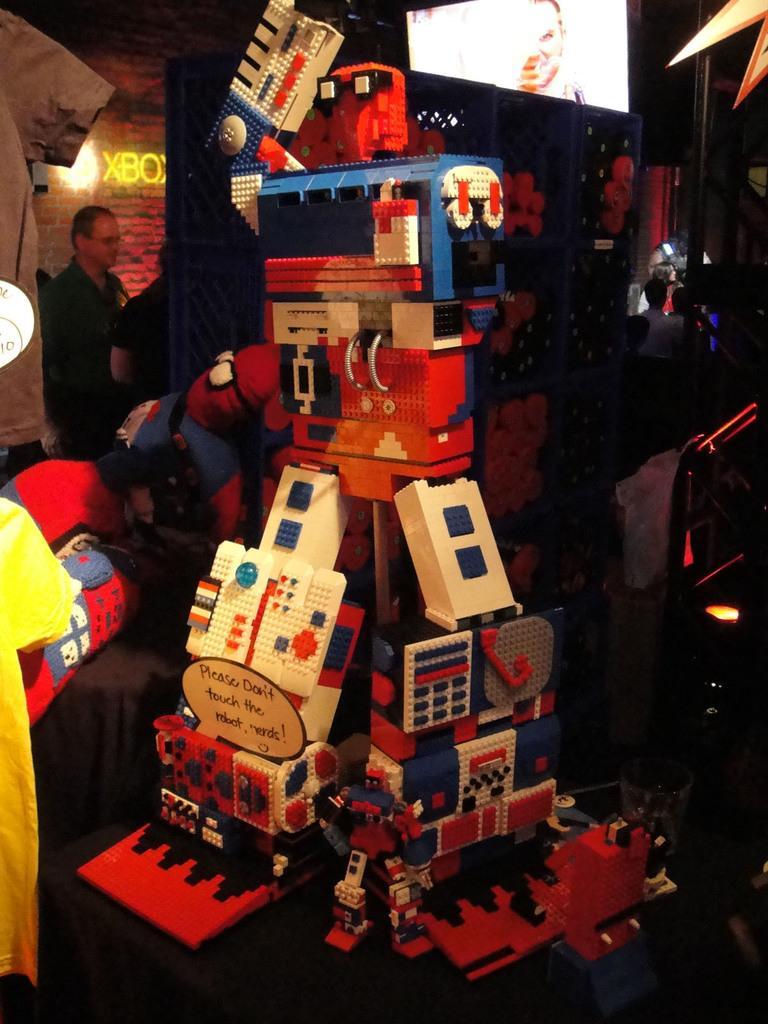Can you describe this image briefly? In the center of the picture we can see a toy made from lego. In the background we can see people, wall, light, television and various objects. On the left we can see a person's cloth. On the right we can see light. At the top towards right it is star. 